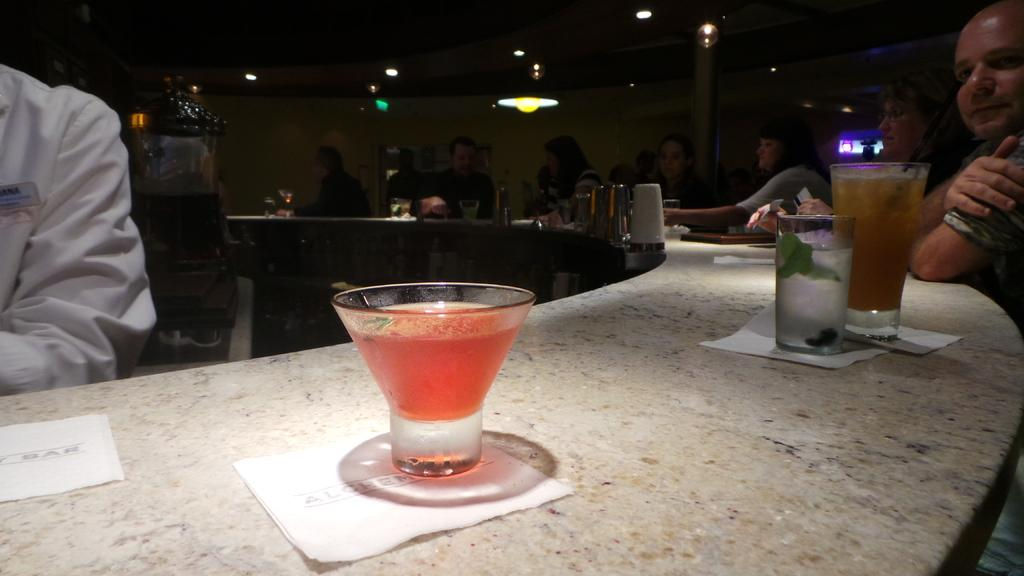Who or what is present in the image? There are people in the image. What objects can be seen on the table? There are glasses and tissues on the table. What other items are on the table? There are other objects on the table. What can be seen in the background of the image? There is a wall visible in the image. What type of lighting is present in the image? There are lights in the image. What architectural feature is present in the image? There is a pillar in the image. What type of work is the representative doing in the image? There is no representative present in the image, and therefore no work can be observed. 